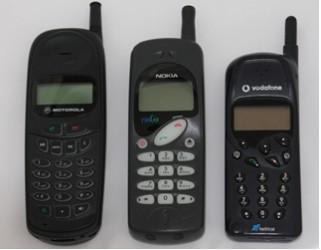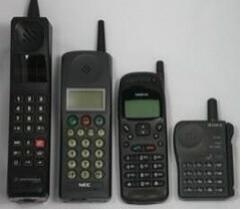The first image is the image on the left, the second image is the image on the right. Given the left and right images, does the statement "In each image, three or more cellphones with keypads and antenna knobs are shown upright and side by side." hold true? Answer yes or no. Yes. The first image is the image on the left, the second image is the image on the right. Examine the images to the left and right. Is the description "There are three black phones in a row with small antennas on the right side." accurate? Answer yes or no. Yes. 